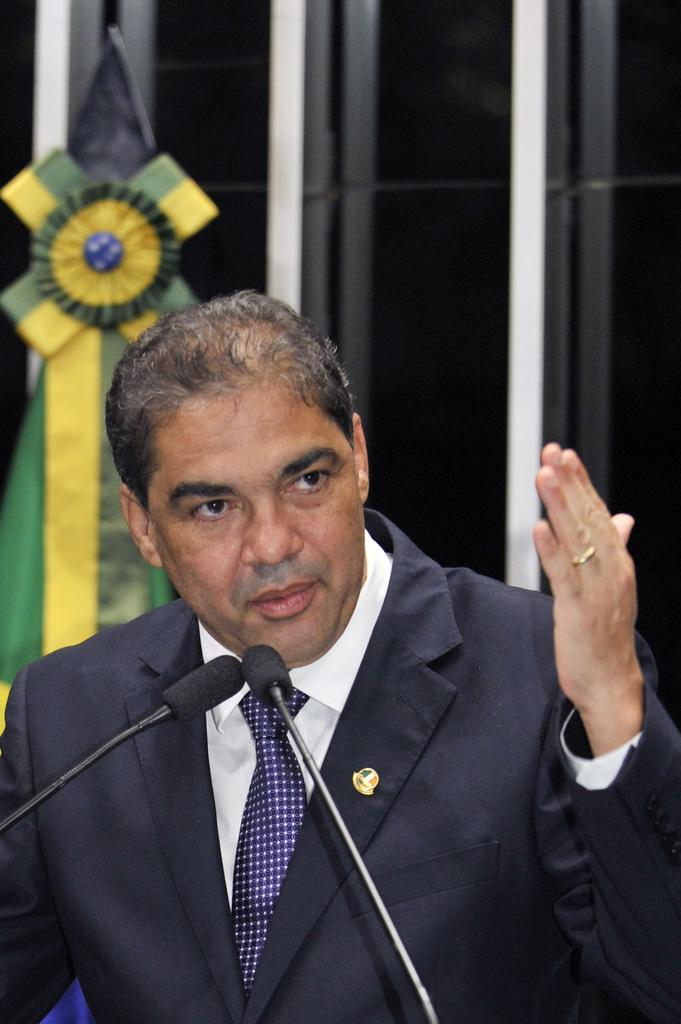What is the main subject of the image? There is a man standing in the image. What is in front of the man? There are microphones in front of the man. What else can be seen in the image? There are other items visible behind the man. How does the man increase the volume of the rail in the image? There is no rail present in the image, and the man is not adjusting any volume. 